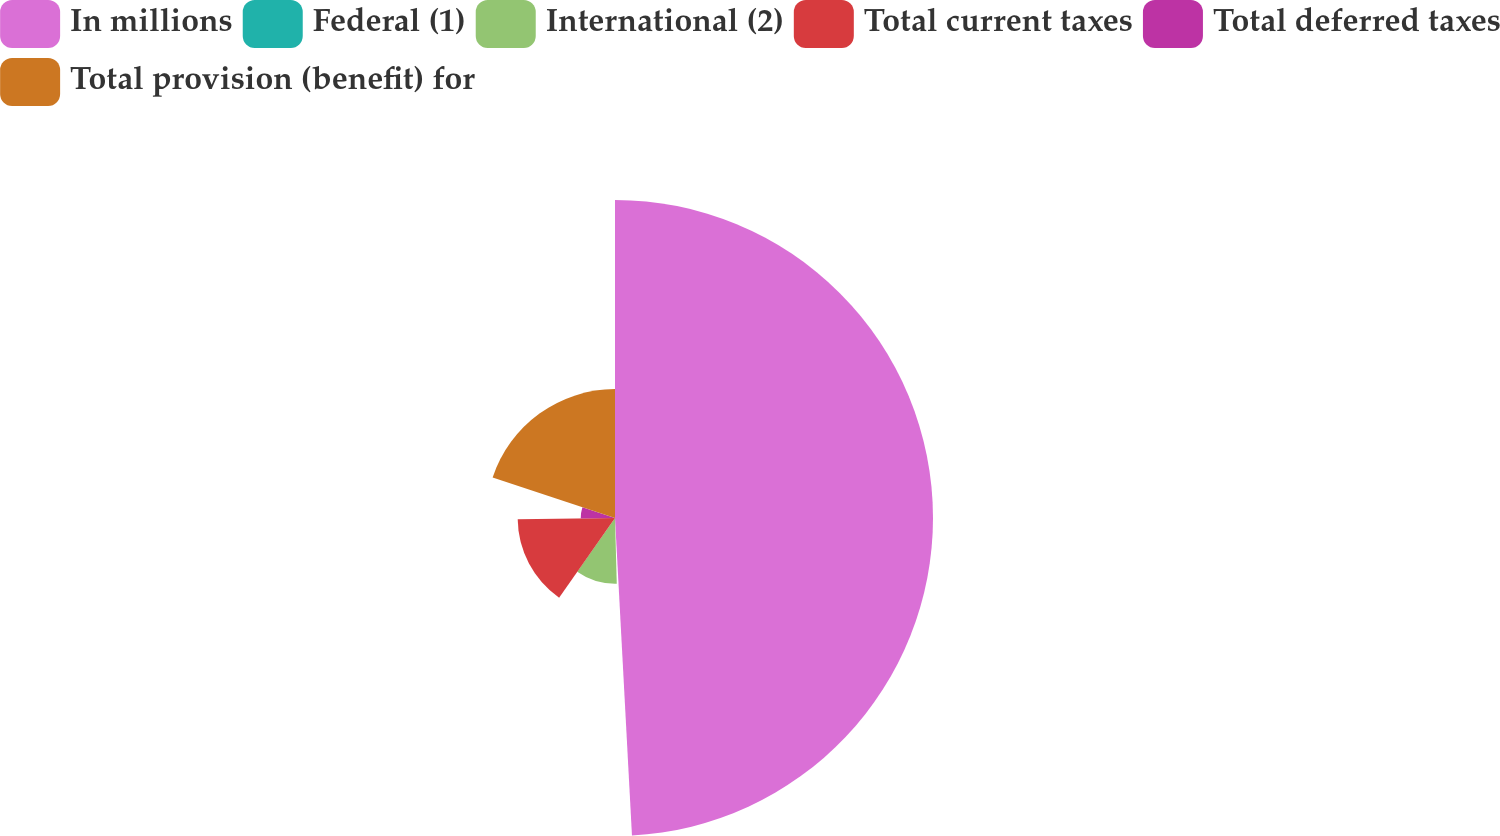Convert chart. <chart><loc_0><loc_0><loc_500><loc_500><pie_chart><fcel>In millions<fcel>Federal (1)<fcel>International (2)<fcel>Total current taxes<fcel>Total deferred taxes<fcel>Total provision (benefit) for<nl><fcel>49.15%<fcel>0.42%<fcel>10.17%<fcel>15.04%<fcel>5.3%<fcel>19.92%<nl></chart> 